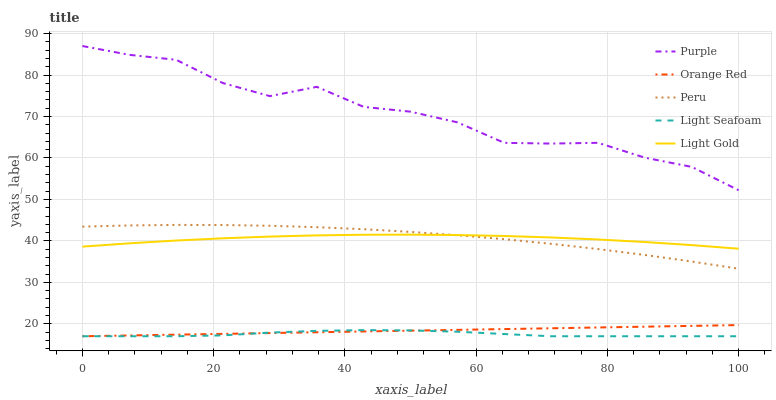Does Light Seafoam have the minimum area under the curve?
Answer yes or no. Yes. Does Purple have the maximum area under the curve?
Answer yes or no. Yes. Does Light Gold have the minimum area under the curve?
Answer yes or no. No. Does Light Gold have the maximum area under the curve?
Answer yes or no. No. Is Orange Red the smoothest?
Answer yes or no. Yes. Is Purple the roughest?
Answer yes or no. Yes. Is Light Seafoam the smoothest?
Answer yes or no. No. Is Light Seafoam the roughest?
Answer yes or no. No. Does Light Seafoam have the lowest value?
Answer yes or no. Yes. Does Light Gold have the lowest value?
Answer yes or no. No. Does Purple have the highest value?
Answer yes or no. Yes. Does Light Gold have the highest value?
Answer yes or no. No. Is Orange Red less than Peru?
Answer yes or no. Yes. Is Light Gold greater than Orange Red?
Answer yes or no. Yes. Does Orange Red intersect Light Seafoam?
Answer yes or no. Yes. Is Orange Red less than Light Seafoam?
Answer yes or no. No. Is Orange Red greater than Light Seafoam?
Answer yes or no. No. Does Orange Red intersect Peru?
Answer yes or no. No. 